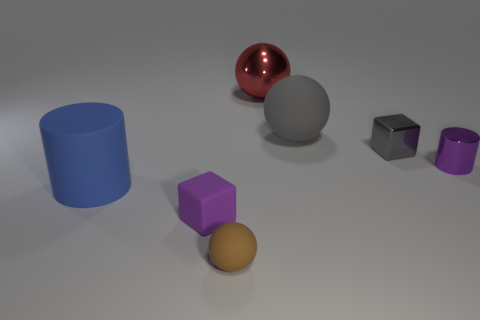There is a shiny thing that is behind the shiny cube; is its shape the same as the purple object behind the large blue thing?
Your answer should be compact. No. There is a purple rubber object; does it have the same size as the purple object that is on the right side of the metal ball?
Ensure brevity in your answer.  Yes. What number of other objects are there of the same material as the large red thing?
Ensure brevity in your answer.  2. Are there any other things that have the same shape as the red metallic object?
Your answer should be very brief. Yes. The small cube to the right of the big rubber thing that is to the right of the block that is on the left side of the large metallic ball is what color?
Provide a succinct answer. Gray. There is a object that is behind the tiny gray metal thing and to the right of the big red thing; what shape is it?
Provide a succinct answer. Sphere. Is there any other thing that is the same size as the purple metallic cylinder?
Provide a succinct answer. Yes. There is a cube right of the big sphere in front of the large shiny object; what color is it?
Ensure brevity in your answer.  Gray. What is the shape of the large thing in front of the large matte thing that is right of the big rubber cylinder in front of the large gray ball?
Your response must be concise. Cylinder. What is the size of the rubber object that is behind the tiny matte block and on the left side of the red ball?
Give a very brief answer. Large. 